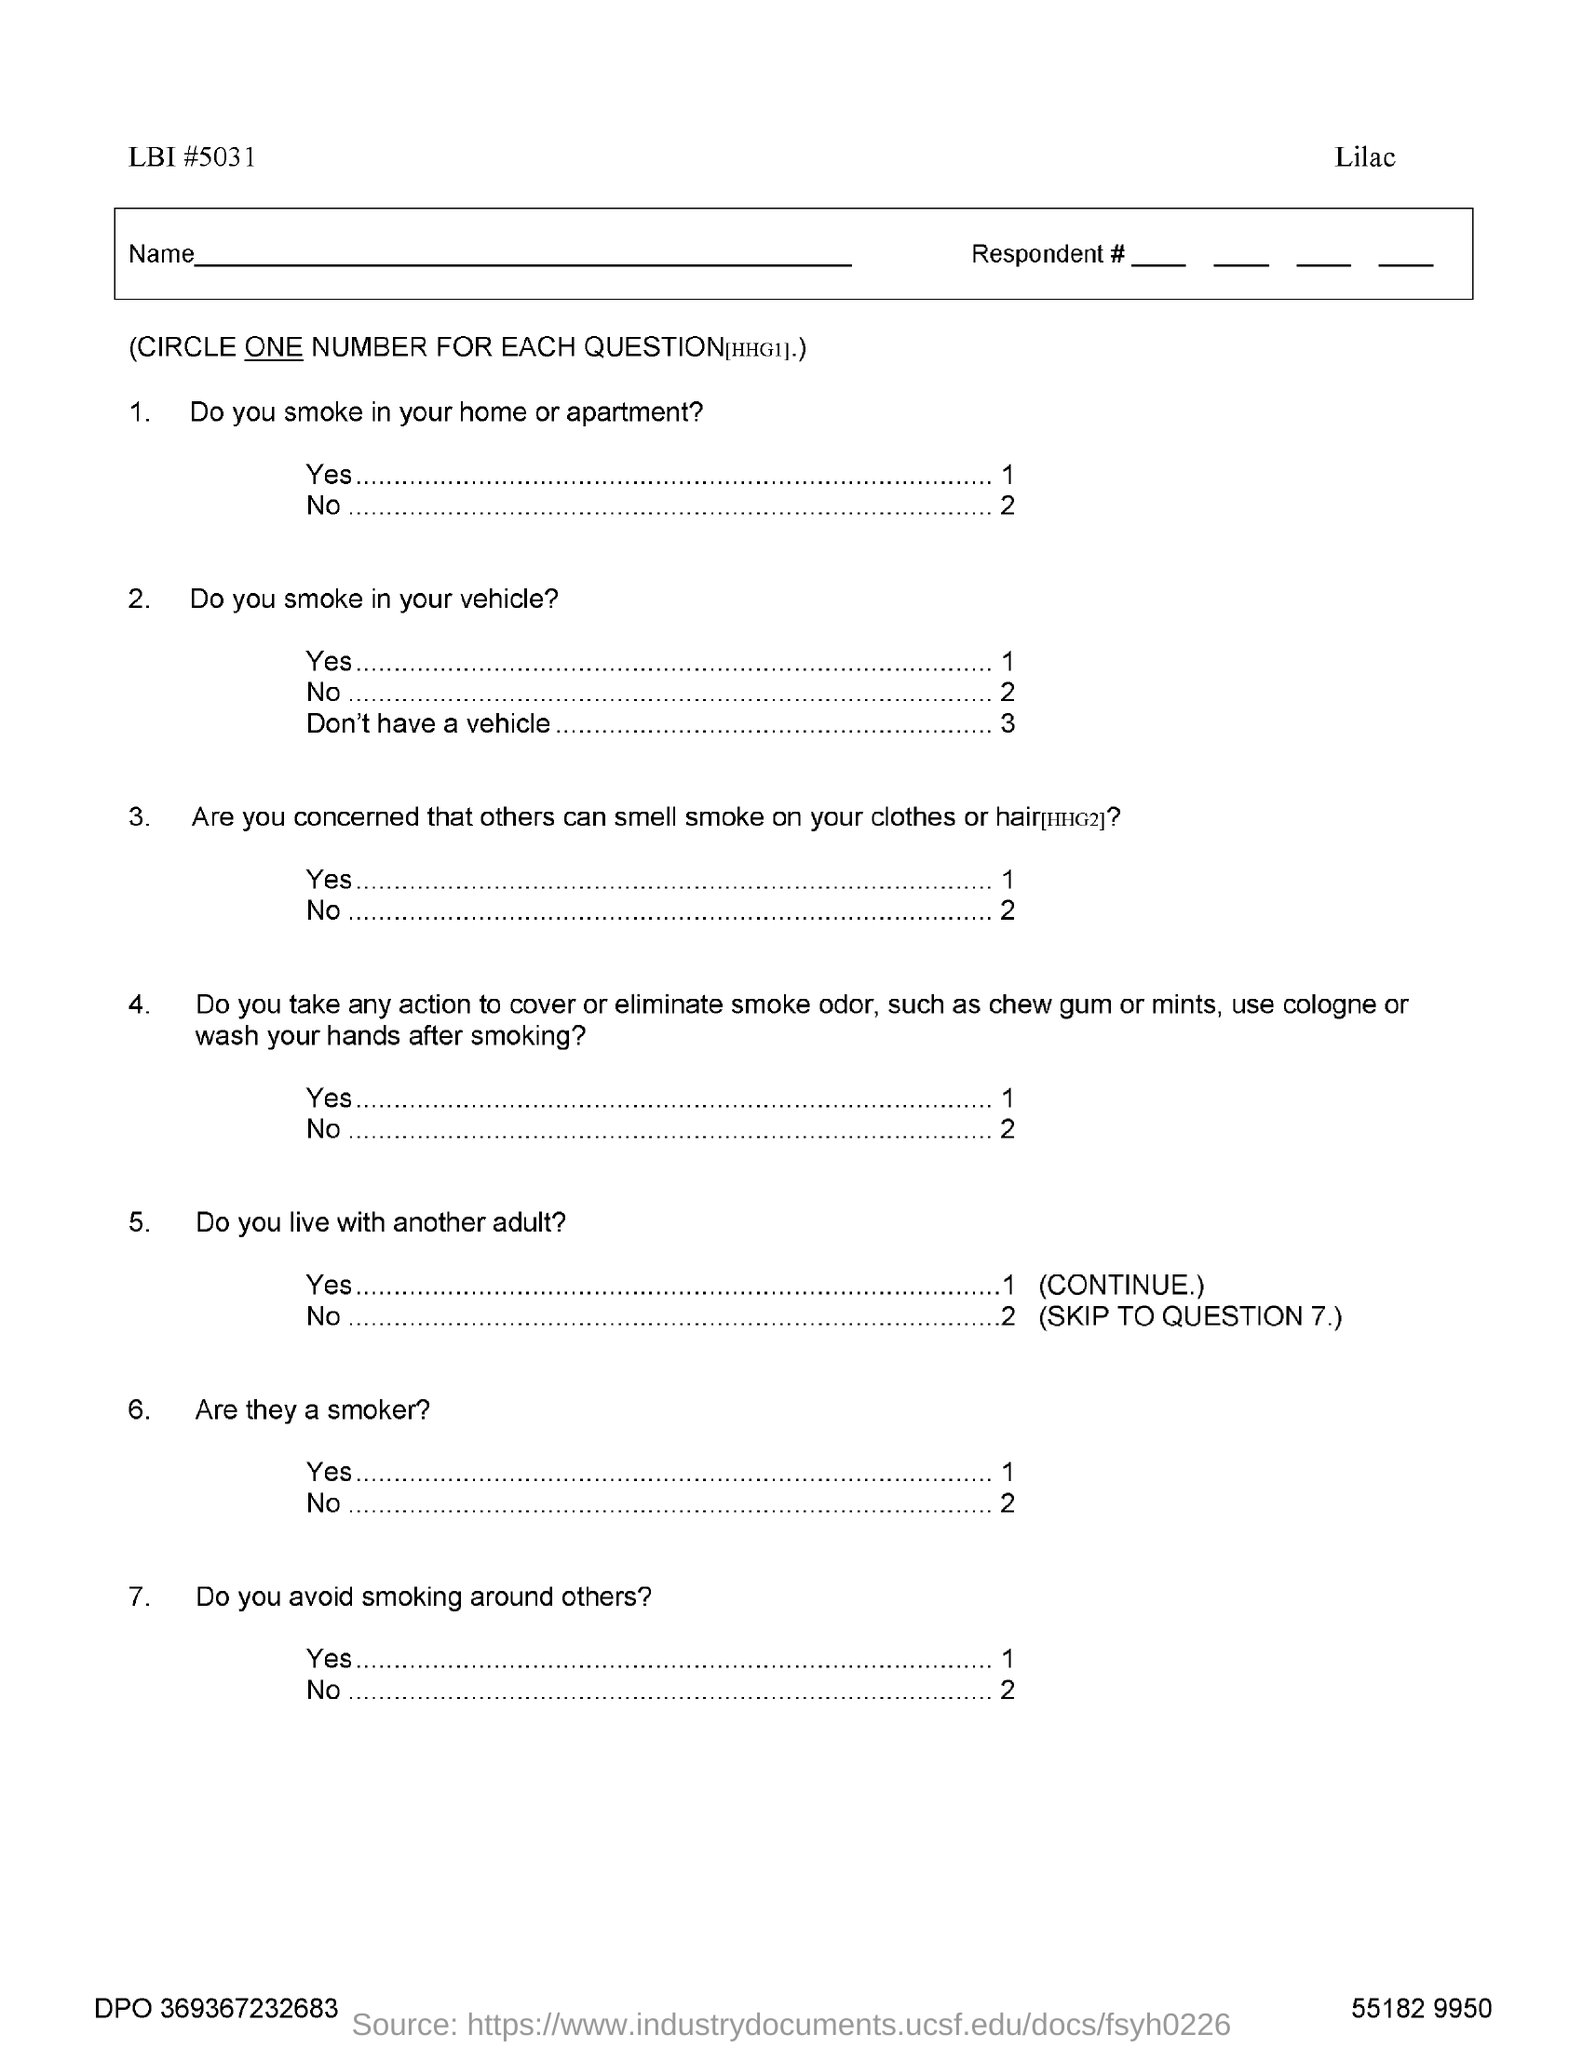What is the LBI #?
Your response must be concise. 5031. 